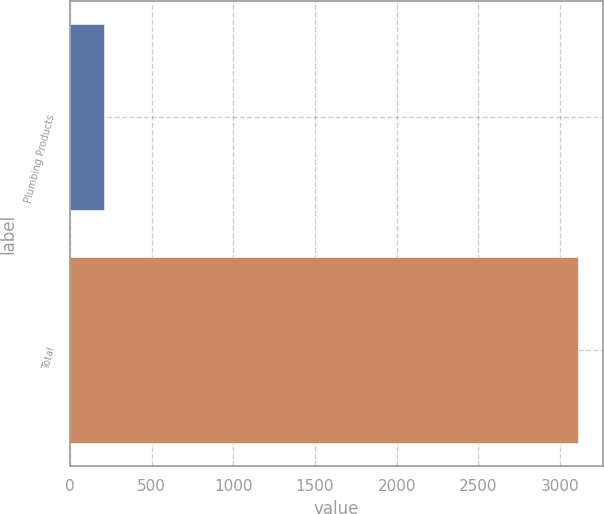Convert chart to OTSL. <chart><loc_0><loc_0><loc_500><loc_500><bar_chart><fcel>Plumbing Products<fcel>Total<nl><fcel>207<fcel>3108<nl></chart> 